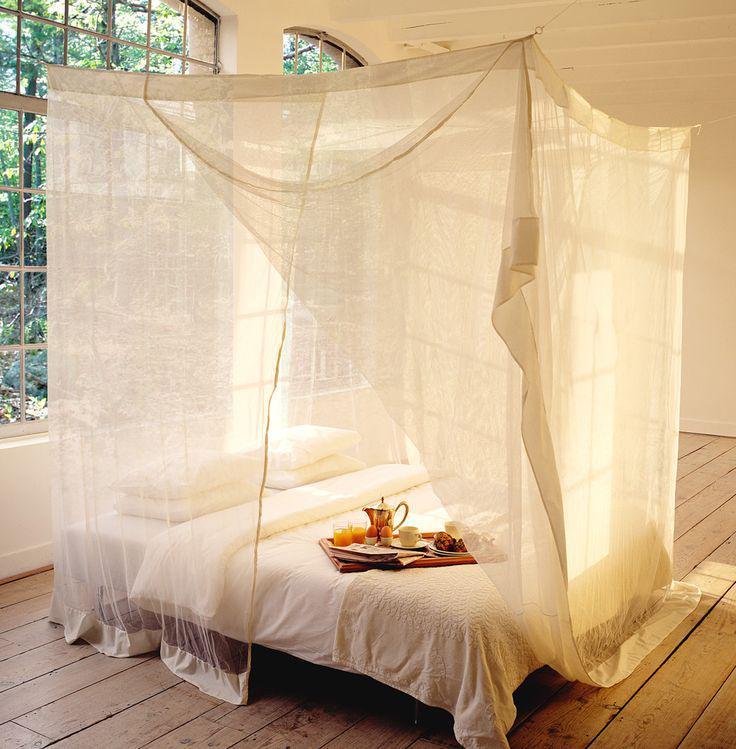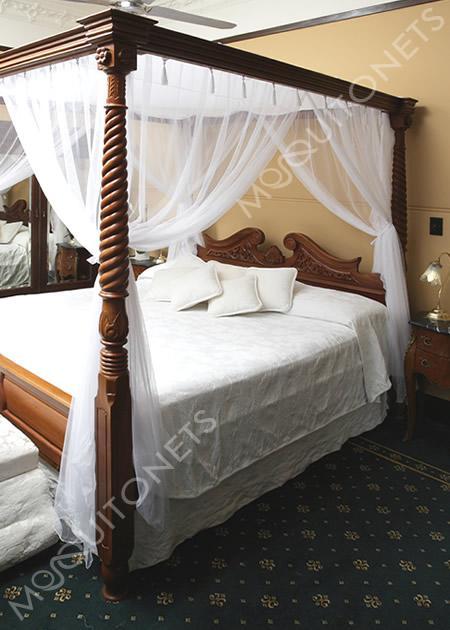The first image is the image on the left, the second image is the image on the right. For the images displayed, is the sentence "At least one bed has a pink canopy." factually correct? Answer yes or no. No. The first image is the image on the left, the second image is the image on the right. For the images displayed, is the sentence "There is a table lamp in the image on the left." factually correct? Answer yes or no. No. 